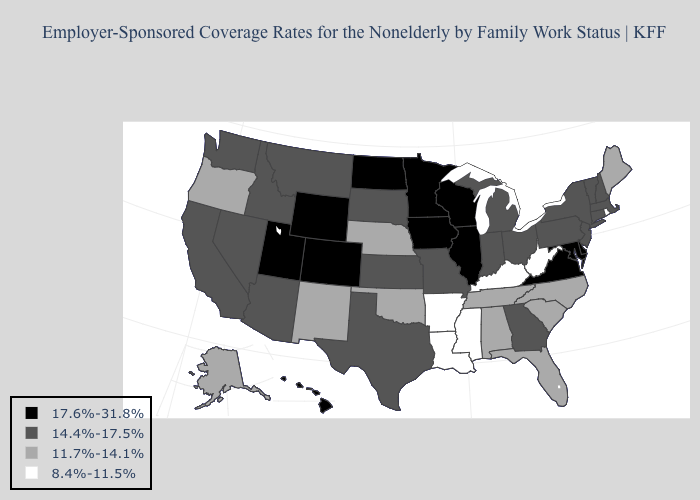What is the value of Nebraska?
Give a very brief answer. 11.7%-14.1%. Does the first symbol in the legend represent the smallest category?
Give a very brief answer. No. Among the states that border Georgia , which have the lowest value?
Write a very short answer. Alabama, Florida, North Carolina, South Carolina, Tennessee. Name the states that have a value in the range 8.4%-11.5%?
Be succinct. Arkansas, Kentucky, Louisiana, Mississippi, Rhode Island, West Virginia. Name the states that have a value in the range 11.7%-14.1%?
Keep it brief. Alabama, Alaska, Florida, Maine, Nebraska, New Mexico, North Carolina, Oklahoma, Oregon, South Carolina, Tennessee. How many symbols are there in the legend?
Answer briefly. 4. Which states hav the highest value in the MidWest?
Give a very brief answer. Illinois, Iowa, Minnesota, North Dakota, Wisconsin. Does Rhode Island have the lowest value in the Northeast?
Short answer required. Yes. What is the value of Nebraska?
Keep it brief. 11.7%-14.1%. Which states have the lowest value in the MidWest?
Answer briefly. Nebraska. Name the states that have a value in the range 8.4%-11.5%?
Quick response, please. Arkansas, Kentucky, Louisiana, Mississippi, Rhode Island, West Virginia. Name the states that have a value in the range 8.4%-11.5%?
Concise answer only. Arkansas, Kentucky, Louisiana, Mississippi, Rhode Island, West Virginia. Which states have the highest value in the USA?
Concise answer only. Colorado, Delaware, Hawaii, Illinois, Iowa, Maryland, Minnesota, North Dakota, Utah, Virginia, Wisconsin, Wyoming. Does the first symbol in the legend represent the smallest category?
Be succinct. No. 